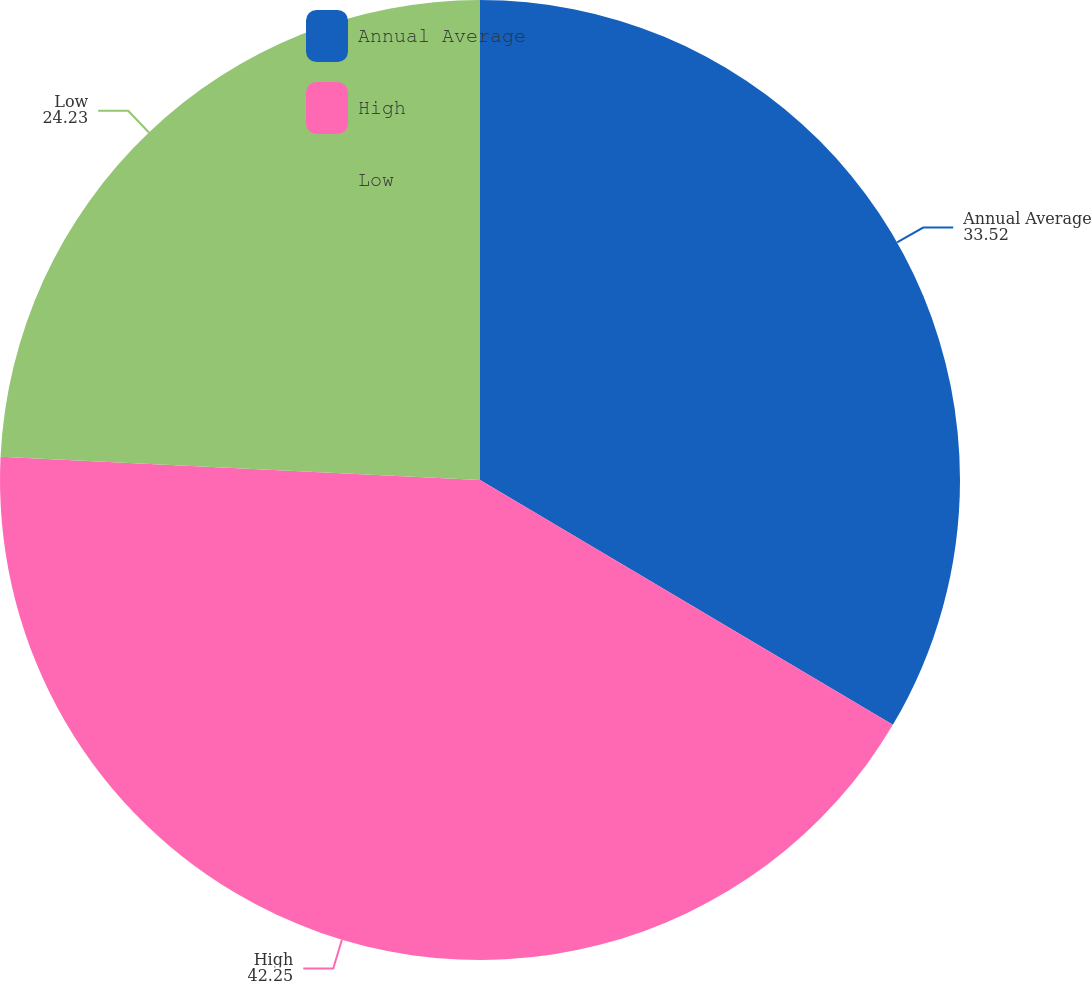Convert chart. <chart><loc_0><loc_0><loc_500><loc_500><pie_chart><fcel>Annual Average<fcel>High<fcel>Low<nl><fcel>33.52%<fcel>42.25%<fcel>24.23%<nl></chart> 